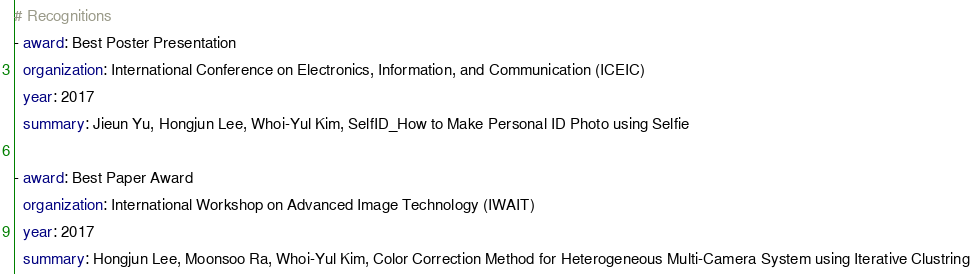<code> <loc_0><loc_0><loc_500><loc_500><_YAML_># Recognitions
- award: Best Poster Presentation
  organization: International Conference on Electronics, Information, and Communication (ICEIC)
  year: 2017
  summary: Jieun Yu, Hongjun Lee, Whoi-Yul Kim, SelfID_How to Make Personal ID Photo using Selfie

- award: Best Paper Award
  organization: International Workshop on Advanced Image Technology (IWAIT)
  year: 2017
  summary: Hongjun Lee, Moonsoo Ra, Whoi-Yul Kim, Color Correction Method for Heterogeneous Multi-Camera System using Iterative Clustring
</code> 